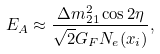<formula> <loc_0><loc_0><loc_500><loc_500>E _ { A } \approx \frac { \Delta m ^ { 2 } _ { 2 1 } \cos 2 \eta } { \sqrt { 2 } G _ { F } N _ { e } ( x _ { i } ) } ,</formula> 